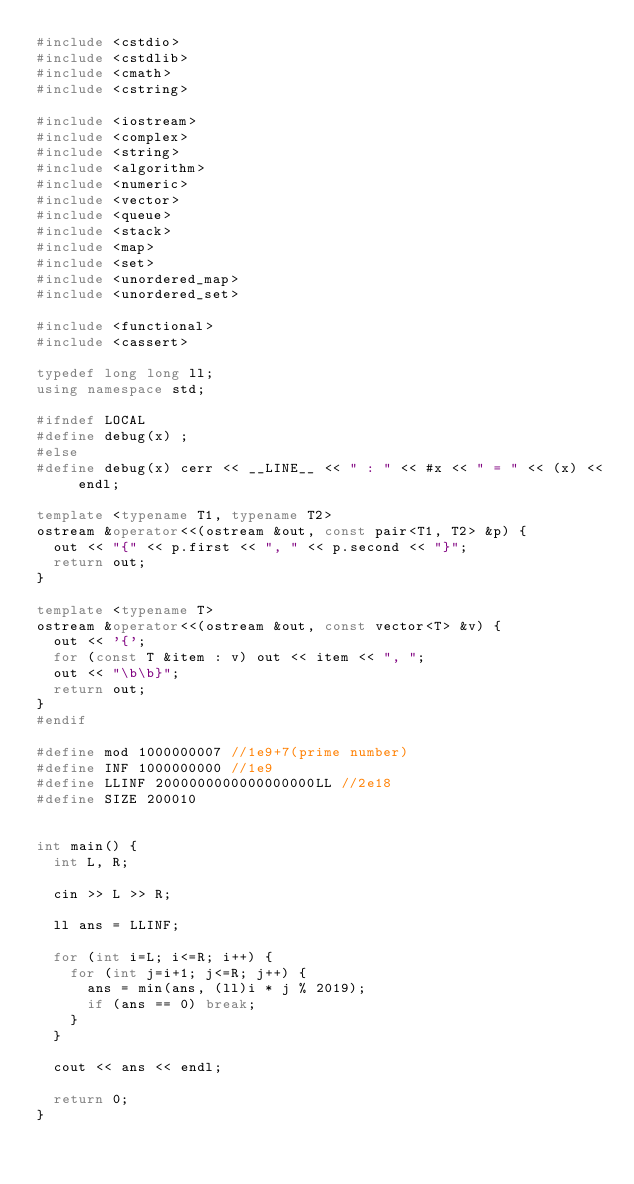<code> <loc_0><loc_0><loc_500><loc_500><_C++_>#include <cstdio>
#include <cstdlib>
#include <cmath>
#include <cstring>

#include <iostream>
#include <complex>
#include <string>
#include <algorithm>
#include <numeric>
#include <vector>
#include <queue>
#include <stack>
#include <map>
#include <set>
#include <unordered_map>
#include <unordered_set>

#include <functional>
#include <cassert>

typedef long long ll;
using namespace std;

#ifndef LOCAL
#define debug(x) ;
#else
#define debug(x) cerr << __LINE__ << " : " << #x << " = " << (x) << endl;

template <typename T1, typename T2>
ostream &operator<<(ostream &out, const pair<T1, T2> &p) {
  out << "{" << p.first << ", " << p.second << "}";
  return out;
}

template <typename T>
ostream &operator<<(ostream &out, const vector<T> &v) {
  out << '{';
  for (const T &item : v) out << item << ", ";
  out << "\b\b}";
  return out;
}
#endif

#define mod 1000000007 //1e9+7(prime number)
#define INF 1000000000 //1e9
#define LLINF 2000000000000000000LL //2e18
#define SIZE 200010


int main() {
  int L, R;

  cin >> L >> R;

  ll ans = LLINF;

  for (int i=L; i<=R; i++) {
    for (int j=i+1; j<=R; j++) {
      ans = min(ans, (ll)i * j % 2019);
      if (ans == 0) break;
    }
  }

  cout << ans << endl;

  return 0;
}
</code> 